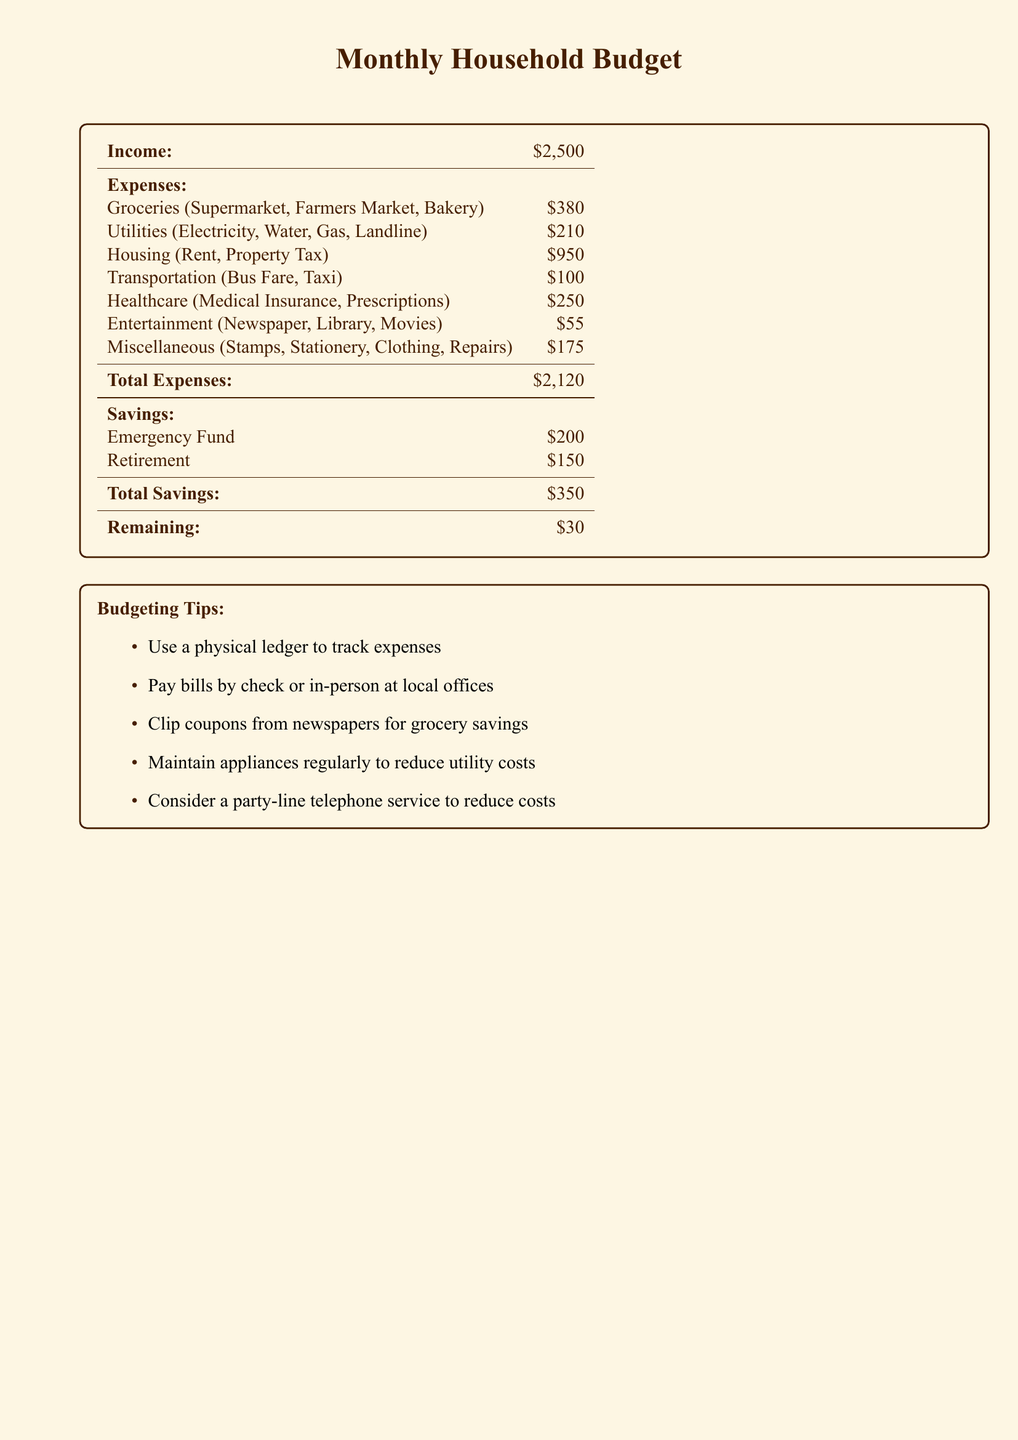What is the total income? The total income is listed at the top of the document as $2,500.
Answer: $2,500 What is the amount spent on groceries? The amount spent on groceries is specified under expenses in the document, which states $380.
Answer: $380 How much is budgeted for utilities? The budgeted amount for utilities, which includes electricity, water, gas, and landline, is mentioned as $210.
Answer: $210 What is the total amount for miscellaneous expenses? The miscellaneous expenses category totals $175 as listed in the expenses section.
Answer: $175 What is the total amount of savings? The total savings, including emergency fund and retirement, is provided in the savings section as $350.
Answer: $350 What is the remaining balance after expenses and savings? The document shows the remaining balance as $30 after expenses and savings are accounted for.
Answer: $30 What percentage of the total income is spent on housing? To find the percentage, we calculate (Housing expenses $950 / Total income $2,500) * 100, which gives us 38%.
Answer: 38% How much is allocated for healthcare? The healthcare category lists the total amount allocated for medical insurance and prescriptions as $250.
Answer: $250 What budgeting tip is suggested for tracking expenses? One recommended budgeting tip in the document is to use a physical ledger to track expenses.
Answer: physical ledger 